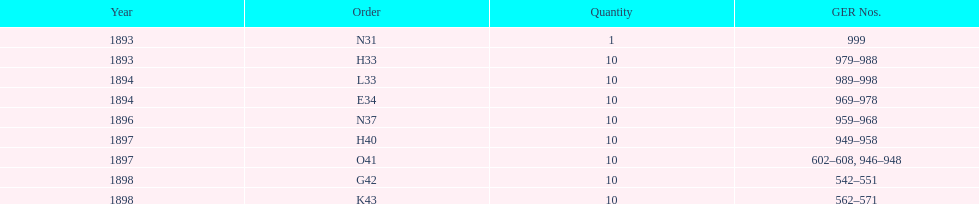Could you help me parse every detail presented in this table? {'header': ['Year', 'Order', 'Quantity', 'GER Nos.'], 'rows': [['1893', 'N31', '1', '999'], ['1893', 'H33', '10', '979–988'], ['1894', 'L33', '10', '989–998'], ['1894', 'E34', '10', '969–978'], ['1896', 'N37', '10', '959–968'], ['1897', 'H40', '10', '949–958'], ['1897', 'O41', '10', '602–608, 946–948'], ['1898', 'G42', '10', '542–551'], ['1898', 'K43', '10', '562–571']]} Which had more ger numbers, 1898 or 1893? 1898. 